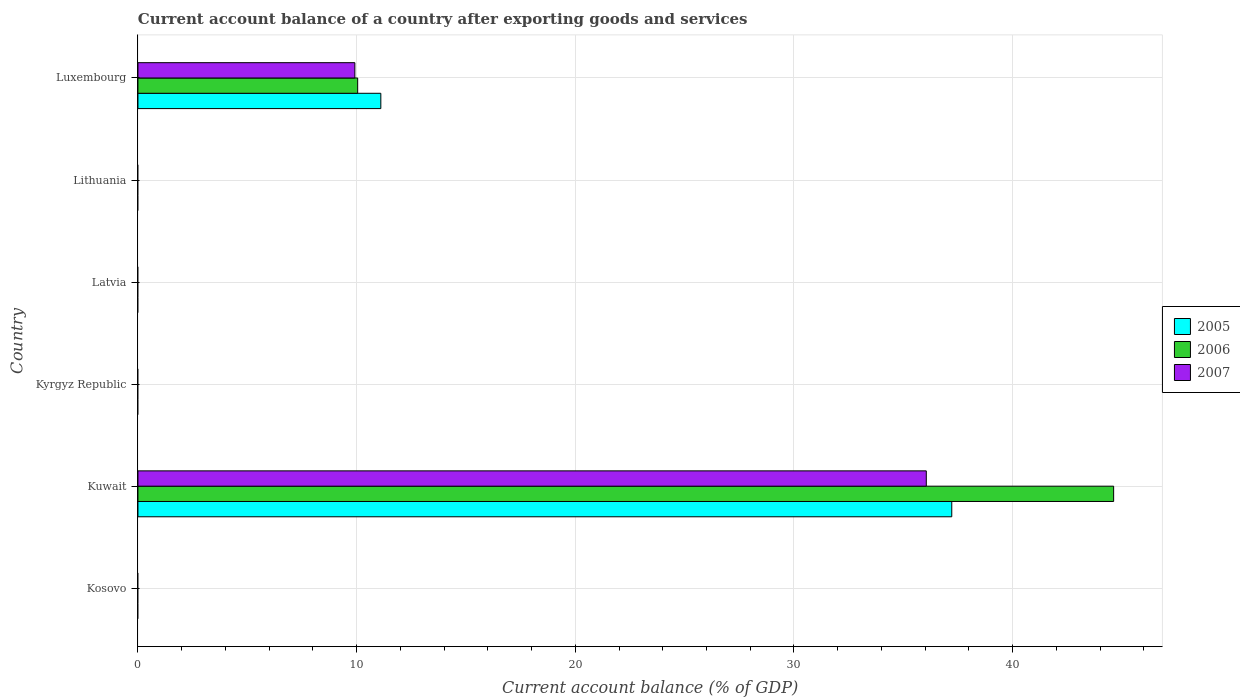Are the number of bars per tick equal to the number of legend labels?
Ensure brevity in your answer.  No. How many bars are there on the 1st tick from the bottom?
Provide a short and direct response. 0. What is the label of the 5th group of bars from the top?
Your answer should be very brief. Kuwait. What is the account balance in 2005 in Kuwait?
Ensure brevity in your answer.  37.22. Across all countries, what is the maximum account balance in 2005?
Give a very brief answer. 37.22. Across all countries, what is the minimum account balance in 2007?
Keep it short and to the point. 0. In which country was the account balance in 2005 maximum?
Your response must be concise. Kuwait. What is the total account balance in 2005 in the graph?
Provide a short and direct response. 48.32. What is the average account balance in 2007 per country?
Offer a very short reply. 7.66. What is the difference between the account balance in 2005 and account balance in 2007 in Luxembourg?
Make the answer very short. 1.19. In how many countries, is the account balance in 2007 greater than 12 %?
Ensure brevity in your answer.  1. What is the difference between the highest and the lowest account balance in 2006?
Make the answer very short. 44.62. Are all the bars in the graph horizontal?
Provide a short and direct response. Yes. How many countries are there in the graph?
Ensure brevity in your answer.  6. Does the graph contain grids?
Give a very brief answer. Yes. How many legend labels are there?
Offer a terse response. 3. How are the legend labels stacked?
Provide a succinct answer. Vertical. What is the title of the graph?
Provide a short and direct response. Current account balance of a country after exporting goods and services. What is the label or title of the X-axis?
Offer a very short reply. Current account balance (% of GDP). What is the Current account balance (% of GDP) of 2005 in Kosovo?
Offer a very short reply. 0. What is the Current account balance (% of GDP) in 2006 in Kosovo?
Offer a very short reply. 0. What is the Current account balance (% of GDP) of 2007 in Kosovo?
Give a very brief answer. 0. What is the Current account balance (% of GDP) of 2005 in Kuwait?
Your answer should be compact. 37.22. What is the Current account balance (% of GDP) in 2006 in Kuwait?
Your answer should be very brief. 44.62. What is the Current account balance (% of GDP) of 2007 in Kuwait?
Ensure brevity in your answer.  36.05. What is the Current account balance (% of GDP) of 2006 in Kyrgyz Republic?
Your answer should be compact. 0. What is the Current account balance (% of GDP) in 2005 in Latvia?
Offer a terse response. 0. What is the Current account balance (% of GDP) in 2007 in Latvia?
Your answer should be compact. 0. What is the Current account balance (% of GDP) in 2007 in Lithuania?
Ensure brevity in your answer.  0. What is the Current account balance (% of GDP) of 2005 in Luxembourg?
Your answer should be very brief. 11.11. What is the Current account balance (% of GDP) of 2006 in Luxembourg?
Make the answer very short. 10.05. What is the Current account balance (% of GDP) in 2007 in Luxembourg?
Your answer should be very brief. 9.92. Across all countries, what is the maximum Current account balance (% of GDP) of 2005?
Give a very brief answer. 37.22. Across all countries, what is the maximum Current account balance (% of GDP) of 2006?
Keep it short and to the point. 44.62. Across all countries, what is the maximum Current account balance (% of GDP) of 2007?
Your response must be concise. 36.05. Across all countries, what is the minimum Current account balance (% of GDP) in 2005?
Provide a succinct answer. 0. Across all countries, what is the minimum Current account balance (% of GDP) of 2007?
Provide a succinct answer. 0. What is the total Current account balance (% of GDP) of 2005 in the graph?
Provide a succinct answer. 48.32. What is the total Current account balance (% of GDP) in 2006 in the graph?
Ensure brevity in your answer.  54.67. What is the total Current account balance (% of GDP) in 2007 in the graph?
Your response must be concise. 45.97. What is the difference between the Current account balance (% of GDP) of 2005 in Kuwait and that in Luxembourg?
Ensure brevity in your answer.  26.11. What is the difference between the Current account balance (% of GDP) of 2006 in Kuwait and that in Luxembourg?
Your answer should be very brief. 34.57. What is the difference between the Current account balance (% of GDP) of 2007 in Kuwait and that in Luxembourg?
Ensure brevity in your answer.  26.13. What is the difference between the Current account balance (% of GDP) of 2005 in Kuwait and the Current account balance (% of GDP) of 2006 in Luxembourg?
Provide a succinct answer. 27.17. What is the difference between the Current account balance (% of GDP) of 2005 in Kuwait and the Current account balance (% of GDP) of 2007 in Luxembourg?
Your answer should be very brief. 27.3. What is the difference between the Current account balance (% of GDP) in 2006 in Kuwait and the Current account balance (% of GDP) in 2007 in Luxembourg?
Keep it short and to the point. 34.7. What is the average Current account balance (% of GDP) of 2005 per country?
Provide a short and direct response. 8.05. What is the average Current account balance (% of GDP) in 2006 per country?
Give a very brief answer. 9.11. What is the average Current account balance (% of GDP) in 2007 per country?
Provide a succinct answer. 7.66. What is the difference between the Current account balance (% of GDP) in 2005 and Current account balance (% of GDP) in 2006 in Kuwait?
Give a very brief answer. -7.4. What is the difference between the Current account balance (% of GDP) in 2005 and Current account balance (% of GDP) in 2007 in Kuwait?
Give a very brief answer. 1.17. What is the difference between the Current account balance (% of GDP) in 2006 and Current account balance (% of GDP) in 2007 in Kuwait?
Your answer should be compact. 8.57. What is the difference between the Current account balance (% of GDP) in 2005 and Current account balance (% of GDP) in 2006 in Luxembourg?
Ensure brevity in your answer.  1.06. What is the difference between the Current account balance (% of GDP) of 2005 and Current account balance (% of GDP) of 2007 in Luxembourg?
Offer a very short reply. 1.19. What is the difference between the Current account balance (% of GDP) in 2006 and Current account balance (% of GDP) in 2007 in Luxembourg?
Offer a very short reply. 0.13. What is the ratio of the Current account balance (% of GDP) in 2005 in Kuwait to that in Luxembourg?
Give a very brief answer. 3.35. What is the ratio of the Current account balance (% of GDP) of 2006 in Kuwait to that in Luxembourg?
Offer a terse response. 4.44. What is the ratio of the Current account balance (% of GDP) in 2007 in Kuwait to that in Luxembourg?
Provide a succinct answer. 3.63. What is the difference between the highest and the lowest Current account balance (% of GDP) in 2005?
Your response must be concise. 37.22. What is the difference between the highest and the lowest Current account balance (% of GDP) in 2006?
Your answer should be very brief. 44.62. What is the difference between the highest and the lowest Current account balance (% of GDP) in 2007?
Give a very brief answer. 36.05. 